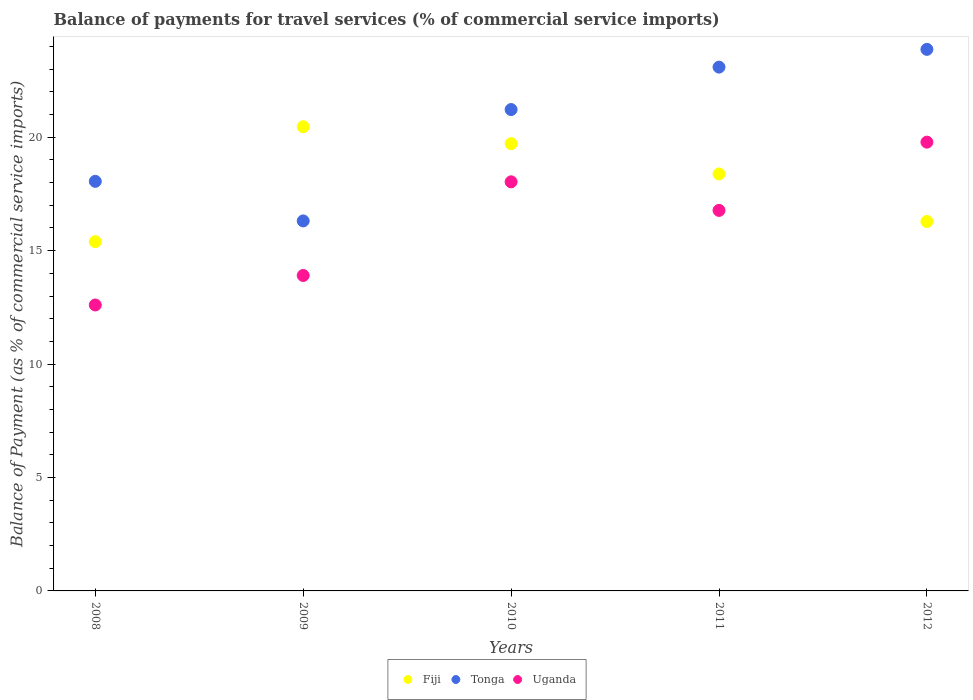What is the balance of payments for travel services in Uganda in 2010?
Your answer should be very brief. 18.03. Across all years, what is the maximum balance of payments for travel services in Fiji?
Give a very brief answer. 20.46. Across all years, what is the minimum balance of payments for travel services in Fiji?
Ensure brevity in your answer.  15.4. What is the total balance of payments for travel services in Tonga in the graph?
Your answer should be compact. 102.55. What is the difference between the balance of payments for travel services in Fiji in 2010 and that in 2011?
Ensure brevity in your answer.  1.34. What is the difference between the balance of payments for travel services in Tonga in 2009 and the balance of payments for travel services in Uganda in 2008?
Make the answer very short. 3.71. What is the average balance of payments for travel services in Fiji per year?
Your answer should be compact. 18.05. In the year 2008, what is the difference between the balance of payments for travel services in Tonga and balance of payments for travel services in Uganda?
Offer a terse response. 5.45. What is the ratio of the balance of payments for travel services in Uganda in 2008 to that in 2010?
Your response must be concise. 0.7. Is the difference between the balance of payments for travel services in Tonga in 2009 and 2010 greater than the difference between the balance of payments for travel services in Uganda in 2009 and 2010?
Your answer should be very brief. No. What is the difference between the highest and the second highest balance of payments for travel services in Tonga?
Keep it short and to the point. 0.78. What is the difference between the highest and the lowest balance of payments for travel services in Uganda?
Give a very brief answer. 7.18. Is the balance of payments for travel services in Uganda strictly greater than the balance of payments for travel services in Fiji over the years?
Offer a terse response. No. Does the graph contain any zero values?
Provide a short and direct response. No. Where does the legend appear in the graph?
Provide a succinct answer. Bottom center. What is the title of the graph?
Your answer should be very brief. Balance of payments for travel services (% of commercial service imports). What is the label or title of the Y-axis?
Your answer should be very brief. Balance of Payment (as % of commercial service imports). What is the Balance of Payment (as % of commercial service imports) in Fiji in 2008?
Ensure brevity in your answer.  15.4. What is the Balance of Payment (as % of commercial service imports) of Tonga in 2008?
Offer a terse response. 18.06. What is the Balance of Payment (as % of commercial service imports) in Uganda in 2008?
Provide a succinct answer. 12.61. What is the Balance of Payment (as % of commercial service imports) in Fiji in 2009?
Keep it short and to the point. 20.46. What is the Balance of Payment (as % of commercial service imports) in Tonga in 2009?
Give a very brief answer. 16.31. What is the Balance of Payment (as % of commercial service imports) of Uganda in 2009?
Provide a succinct answer. 13.91. What is the Balance of Payment (as % of commercial service imports) of Fiji in 2010?
Provide a short and direct response. 19.72. What is the Balance of Payment (as % of commercial service imports) in Tonga in 2010?
Your response must be concise. 21.22. What is the Balance of Payment (as % of commercial service imports) in Uganda in 2010?
Your answer should be compact. 18.03. What is the Balance of Payment (as % of commercial service imports) in Fiji in 2011?
Your answer should be very brief. 18.38. What is the Balance of Payment (as % of commercial service imports) of Tonga in 2011?
Give a very brief answer. 23.09. What is the Balance of Payment (as % of commercial service imports) in Uganda in 2011?
Give a very brief answer. 16.77. What is the Balance of Payment (as % of commercial service imports) of Fiji in 2012?
Provide a short and direct response. 16.28. What is the Balance of Payment (as % of commercial service imports) of Tonga in 2012?
Keep it short and to the point. 23.87. What is the Balance of Payment (as % of commercial service imports) of Uganda in 2012?
Provide a short and direct response. 19.78. Across all years, what is the maximum Balance of Payment (as % of commercial service imports) of Fiji?
Provide a short and direct response. 20.46. Across all years, what is the maximum Balance of Payment (as % of commercial service imports) of Tonga?
Ensure brevity in your answer.  23.87. Across all years, what is the maximum Balance of Payment (as % of commercial service imports) of Uganda?
Provide a succinct answer. 19.78. Across all years, what is the minimum Balance of Payment (as % of commercial service imports) in Fiji?
Keep it short and to the point. 15.4. Across all years, what is the minimum Balance of Payment (as % of commercial service imports) in Tonga?
Make the answer very short. 16.31. Across all years, what is the minimum Balance of Payment (as % of commercial service imports) in Uganda?
Your response must be concise. 12.61. What is the total Balance of Payment (as % of commercial service imports) in Fiji in the graph?
Offer a very short reply. 90.24. What is the total Balance of Payment (as % of commercial service imports) in Tonga in the graph?
Your answer should be compact. 102.55. What is the total Balance of Payment (as % of commercial service imports) in Uganda in the graph?
Offer a very short reply. 81.1. What is the difference between the Balance of Payment (as % of commercial service imports) of Fiji in 2008 and that in 2009?
Keep it short and to the point. -5.07. What is the difference between the Balance of Payment (as % of commercial service imports) of Tonga in 2008 and that in 2009?
Offer a very short reply. 1.74. What is the difference between the Balance of Payment (as % of commercial service imports) in Uganda in 2008 and that in 2009?
Your answer should be very brief. -1.3. What is the difference between the Balance of Payment (as % of commercial service imports) in Fiji in 2008 and that in 2010?
Provide a short and direct response. -4.32. What is the difference between the Balance of Payment (as % of commercial service imports) of Tonga in 2008 and that in 2010?
Make the answer very short. -3.16. What is the difference between the Balance of Payment (as % of commercial service imports) in Uganda in 2008 and that in 2010?
Give a very brief answer. -5.43. What is the difference between the Balance of Payment (as % of commercial service imports) in Fiji in 2008 and that in 2011?
Keep it short and to the point. -2.98. What is the difference between the Balance of Payment (as % of commercial service imports) of Tonga in 2008 and that in 2011?
Ensure brevity in your answer.  -5.03. What is the difference between the Balance of Payment (as % of commercial service imports) of Uganda in 2008 and that in 2011?
Ensure brevity in your answer.  -4.17. What is the difference between the Balance of Payment (as % of commercial service imports) in Fiji in 2008 and that in 2012?
Give a very brief answer. -0.89. What is the difference between the Balance of Payment (as % of commercial service imports) in Tonga in 2008 and that in 2012?
Your response must be concise. -5.82. What is the difference between the Balance of Payment (as % of commercial service imports) of Uganda in 2008 and that in 2012?
Offer a terse response. -7.18. What is the difference between the Balance of Payment (as % of commercial service imports) of Fiji in 2009 and that in 2010?
Provide a succinct answer. 0.75. What is the difference between the Balance of Payment (as % of commercial service imports) of Tonga in 2009 and that in 2010?
Provide a succinct answer. -4.91. What is the difference between the Balance of Payment (as % of commercial service imports) in Uganda in 2009 and that in 2010?
Provide a short and direct response. -4.13. What is the difference between the Balance of Payment (as % of commercial service imports) in Fiji in 2009 and that in 2011?
Your response must be concise. 2.08. What is the difference between the Balance of Payment (as % of commercial service imports) in Tonga in 2009 and that in 2011?
Give a very brief answer. -6.78. What is the difference between the Balance of Payment (as % of commercial service imports) in Uganda in 2009 and that in 2011?
Ensure brevity in your answer.  -2.87. What is the difference between the Balance of Payment (as % of commercial service imports) of Fiji in 2009 and that in 2012?
Make the answer very short. 4.18. What is the difference between the Balance of Payment (as % of commercial service imports) of Tonga in 2009 and that in 2012?
Your response must be concise. -7.56. What is the difference between the Balance of Payment (as % of commercial service imports) in Uganda in 2009 and that in 2012?
Keep it short and to the point. -5.88. What is the difference between the Balance of Payment (as % of commercial service imports) of Fiji in 2010 and that in 2011?
Keep it short and to the point. 1.34. What is the difference between the Balance of Payment (as % of commercial service imports) in Tonga in 2010 and that in 2011?
Your answer should be very brief. -1.87. What is the difference between the Balance of Payment (as % of commercial service imports) in Uganda in 2010 and that in 2011?
Give a very brief answer. 1.26. What is the difference between the Balance of Payment (as % of commercial service imports) of Fiji in 2010 and that in 2012?
Your answer should be compact. 3.43. What is the difference between the Balance of Payment (as % of commercial service imports) of Tonga in 2010 and that in 2012?
Offer a terse response. -2.65. What is the difference between the Balance of Payment (as % of commercial service imports) of Uganda in 2010 and that in 2012?
Ensure brevity in your answer.  -1.75. What is the difference between the Balance of Payment (as % of commercial service imports) of Fiji in 2011 and that in 2012?
Provide a succinct answer. 2.1. What is the difference between the Balance of Payment (as % of commercial service imports) of Tonga in 2011 and that in 2012?
Your response must be concise. -0.78. What is the difference between the Balance of Payment (as % of commercial service imports) in Uganda in 2011 and that in 2012?
Provide a succinct answer. -3.01. What is the difference between the Balance of Payment (as % of commercial service imports) in Fiji in 2008 and the Balance of Payment (as % of commercial service imports) in Tonga in 2009?
Ensure brevity in your answer.  -0.91. What is the difference between the Balance of Payment (as % of commercial service imports) in Fiji in 2008 and the Balance of Payment (as % of commercial service imports) in Uganda in 2009?
Ensure brevity in your answer.  1.49. What is the difference between the Balance of Payment (as % of commercial service imports) of Tonga in 2008 and the Balance of Payment (as % of commercial service imports) of Uganda in 2009?
Offer a terse response. 4.15. What is the difference between the Balance of Payment (as % of commercial service imports) in Fiji in 2008 and the Balance of Payment (as % of commercial service imports) in Tonga in 2010?
Provide a short and direct response. -5.82. What is the difference between the Balance of Payment (as % of commercial service imports) of Fiji in 2008 and the Balance of Payment (as % of commercial service imports) of Uganda in 2010?
Keep it short and to the point. -2.64. What is the difference between the Balance of Payment (as % of commercial service imports) of Tonga in 2008 and the Balance of Payment (as % of commercial service imports) of Uganda in 2010?
Your answer should be compact. 0.02. What is the difference between the Balance of Payment (as % of commercial service imports) of Fiji in 2008 and the Balance of Payment (as % of commercial service imports) of Tonga in 2011?
Offer a terse response. -7.69. What is the difference between the Balance of Payment (as % of commercial service imports) in Fiji in 2008 and the Balance of Payment (as % of commercial service imports) in Uganda in 2011?
Your response must be concise. -1.38. What is the difference between the Balance of Payment (as % of commercial service imports) of Tonga in 2008 and the Balance of Payment (as % of commercial service imports) of Uganda in 2011?
Your answer should be compact. 1.28. What is the difference between the Balance of Payment (as % of commercial service imports) of Fiji in 2008 and the Balance of Payment (as % of commercial service imports) of Tonga in 2012?
Provide a short and direct response. -8.48. What is the difference between the Balance of Payment (as % of commercial service imports) in Fiji in 2008 and the Balance of Payment (as % of commercial service imports) in Uganda in 2012?
Your response must be concise. -4.39. What is the difference between the Balance of Payment (as % of commercial service imports) in Tonga in 2008 and the Balance of Payment (as % of commercial service imports) in Uganda in 2012?
Your answer should be very brief. -1.73. What is the difference between the Balance of Payment (as % of commercial service imports) in Fiji in 2009 and the Balance of Payment (as % of commercial service imports) in Tonga in 2010?
Provide a short and direct response. -0.76. What is the difference between the Balance of Payment (as % of commercial service imports) in Fiji in 2009 and the Balance of Payment (as % of commercial service imports) in Uganda in 2010?
Provide a short and direct response. 2.43. What is the difference between the Balance of Payment (as % of commercial service imports) in Tonga in 2009 and the Balance of Payment (as % of commercial service imports) in Uganda in 2010?
Your response must be concise. -1.72. What is the difference between the Balance of Payment (as % of commercial service imports) in Fiji in 2009 and the Balance of Payment (as % of commercial service imports) in Tonga in 2011?
Offer a terse response. -2.63. What is the difference between the Balance of Payment (as % of commercial service imports) of Fiji in 2009 and the Balance of Payment (as % of commercial service imports) of Uganda in 2011?
Offer a very short reply. 3.69. What is the difference between the Balance of Payment (as % of commercial service imports) of Tonga in 2009 and the Balance of Payment (as % of commercial service imports) of Uganda in 2011?
Provide a succinct answer. -0.46. What is the difference between the Balance of Payment (as % of commercial service imports) of Fiji in 2009 and the Balance of Payment (as % of commercial service imports) of Tonga in 2012?
Your answer should be very brief. -3.41. What is the difference between the Balance of Payment (as % of commercial service imports) of Fiji in 2009 and the Balance of Payment (as % of commercial service imports) of Uganda in 2012?
Keep it short and to the point. 0.68. What is the difference between the Balance of Payment (as % of commercial service imports) of Tonga in 2009 and the Balance of Payment (as % of commercial service imports) of Uganda in 2012?
Provide a short and direct response. -3.47. What is the difference between the Balance of Payment (as % of commercial service imports) of Fiji in 2010 and the Balance of Payment (as % of commercial service imports) of Tonga in 2011?
Keep it short and to the point. -3.37. What is the difference between the Balance of Payment (as % of commercial service imports) of Fiji in 2010 and the Balance of Payment (as % of commercial service imports) of Uganda in 2011?
Your answer should be compact. 2.94. What is the difference between the Balance of Payment (as % of commercial service imports) of Tonga in 2010 and the Balance of Payment (as % of commercial service imports) of Uganda in 2011?
Your answer should be very brief. 4.45. What is the difference between the Balance of Payment (as % of commercial service imports) of Fiji in 2010 and the Balance of Payment (as % of commercial service imports) of Tonga in 2012?
Your answer should be very brief. -4.16. What is the difference between the Balance of Payment (as % of commercial service imports) of Fiji in 2010 and the Balance of Payment (as % of commercial service imports) of Uganda in 2012?
Provide a succinct answer. -0.07. What is the difference between the Balance of Payment (as % of commercial service imports) in Tonga in 2010 and the Balance of Payment (as % of commercial service imports) in Uganda in 2012?
Your response must be concise. 1.44. What is the difference between the Balance of Payment (as % of commercial service imports) in Fiji in 2011 and the Balance of Payment (as % of commercial service imports) in Tonga in 2012?
Provide a short and direct response. -5.49. What is the difference between the Balance of Payment (as % of commercial service imports) of Fiji in 2011 and the Balance of Payment (as % of commercial service imports) of Uganda in 2012?
Your answer should be very brief. -1.4. What is the difference between the Balance of Payment (as % of commercial service imports) in Tonga in 2011 and the Balance of Payment (as % of commercial service imports) in Uganda in 2012?
Offer a very short reply. 3.31. What is the average Balance of Payment (as % of commercial service imports) in Fiji per year?
Make the answer very short. 18.05. What is the average Balance of Payment (as % of commercial service imports) of Tonga per year?
Offer a terse response. 20.51. What is the average Balance of Payment (as % of commercial service imports) of Uganda per year?
Offer a terse response. 16.22. In the year 2008, what is the difference between the Balance of Payment (as % of commercial service imports) of Fiji and Balance of Payment (as % of commercial service imports) of Tonga?
Your response must be concise. -2.66. In the year 2008, what is the difference between the Balance of Payment (as % of commercial service imports) in Fiji and Balance of Payment (as % of commercial service imports) in Uganda?
Your answer should be compact. 2.79. In the year 2008, what is the difference between the Balance of Payment (as % of commercial service imports) in Tonga and Balance of Payment (as % of commercial service imports) in Uganda?
Your answer should be very brief. 5.45. In the year 2009, what is the difference between the Balance of Payment (as % of commercial service imports) in Fiji and Balance of Payment (as % of commercial service imports) in Tonga?
Your answer should be compact. 4.15. In the year 2009, what is the difference between the Balance of Payment (as % of commercial service imports) of Fiji and Balance of Payment (as % of commercial service imports) of Uganda?
Provide a short and direct response. 6.56. In the year 2009, what is the difference between the Balance of Payment (as % of commercial service imports) of Tonga and Balance of Payment (as % of commercial service imports) of Uganda?
Offer a terse response. 2.41. In the year 2010, what is the difference between the Balance of Payment (as % of commercial service imports) of Fiji and Balance of Payment (as % of commercial service imports) of Tonga?
Provide a short and direct response. -1.5. In the year 2010, what is the difference between the Balance of Payment (as % of commercial service imports) of Fiji and Balance of Payment (as % of commercial service imports) of Uganda?
Offer a terse response. 1.68. In the year 2010, what is the difference between the Balance of Payment (as % of commercial service imports) of Tonga and Balance of Payment (as % of commercial service imports) of Uganda?
Offer a terse response. 3.19. In the year 2011, what is the difference between the Balance of Payment (as % of commercial service imports) of Fiji and Balance of Payment (as % of commercial service imports) of Tonga?
Provide a succinct answer. -4.71. In the year 2011, what is the difference between the Balance of Payment (as % of commercial service imports) of Fiji and Balance of Payment (as % of commercial service imports) of Uganda?
Offer a very short reply. 1.61. In the year 2011, what is the difference between the Balance of Payment (as % of commercial service imports) of Tonga and Balance of Payment (as % of commercial service imports) of Uganda?
Keep it short and to the point. 6.32. In the year 2012, what is the difference between the Balance of Payment (as % of commercial service imports) in Fiji and Balance of Payment (as % of commercial service imports) in Tonga?
Your response must be concise. -7.59. In the year 2012, what is the difference between the Balance of Payment (as % of commercial service imports) in Fiji and Balance of Payment (as % of commercial service imports) in Uganda?
Provide a short and direct response. -3.5. In the year 2012, what is the difference between the Balance of Payment (as % of commercial service imports) in Tonga and Balance of Payment (as % of commercial service imports) in Uganda?
Your response must be concise. 4.09. What is the ratio of the Balance of Payment (as % of commercial service imports) in Fiji in 2008 to that in 2009?
Keep it short and to the point. 0.75. What is the ratio of the Balance of Payment (as % of commercial service imports) in Tonga in 2008 to that in 2009?
Make the answer very short. 1.11. What is the ratio of the Balance of Payment (as % of commercial service imports) in Uganda in 2008 to that in 2009?
Make the answer very short. 0.91. What is the ratio of the Balance of Payment (as % of commercial service imports) of Fiji in 2008 to that in 2010?
Keep it short and to the point. 0.78. What is the ratio of the Balance of Payment (as % of commercial service imports) of Tonga in 2008 to that in 2010?
Give a very brief answer. 0.85. What is the ratio of the Balance of Payment (as % of commercial service imports) in Uganda in 2008 to that in 2010?
Provide a short and direct response. 0.7. What is the ratio of the Balance of Payment (as % of commercial service imports) in Fiji in 2008 to that in 2011?
Your answer should be very brief. 0.84. What is the ratio of the Balance of Payment (as % of commercial service imports) in Tonga in 2008 to that in 2011?
Ensure brevity in your answer.  0.78. What is the ratio of the Balance of Payment (as % of commercial service imports) of Uganda in 2008 to that in 2011?
Offer a terse response. 0.75. What is the ratio of the Balance of Payment (as % of commercial service imports) of Fiji in 2008 to that in 2012?
Provide a succinct answer. 0.95. What is the ratio of the Balance of Payment (as % of commercial service imports) in Tonga in 2008 to that in 2012?
Make the answer very short. 0.76. What is the ratio of the Balance of Payment (as % of commercial service imports) of Uganda in 2008 to that in 2012?
Offer a very short reply. 0.64. What is the ratio of the Balance of Payment (as % of commercial service imports) in Fiji in 2009 to that in 2010?
Give a very brief answer. 1.04. What is the ratio of the Balance of Payment (as % of commercial service imports) of Tonga in 2009 to that in 2010?
Offer a very short reply. 0.77. What is the ratio of the Balance of Payment (as % of commercial service imports) of Uganda in 2009 to that in 2010?
Offer a very short reply. 0.77. What is the ratio of the Balance of Payment (as % of commercial service imports) in Fiji in 2009 to that in 2011?
Your answer should be compact. 1.11. What is the ratio of the Balance of Payment (as % of commercial service imports) of Tonga in 2009 to that in 2011?
Make the answer very short. 0.71. What is the ratio of the Balance of Payment (as % of commercial service imports) in Uganda in 2009 to that in 2011?
Ensure brevity in your answer.  0.83. What is the ratio of the Balance of Payment (as % of commercial service imports) of Fiji in 2009 to that in 2012?
Your response must be concise. 1.26. What is the ratio of the Balance of Payment (as % of commercial service imports) of Tonga in 2009 to that in 2012?
Offer a terse response. 0.68. What is the ratio of the Balance of Payment (as % of commercial service imports) in Uganda in 2009 to that in 2012?
Your answer should be compact. 0.7. What is the ratio of the Balance of Payment (as % of commercial service imports) in Fiji in 2010 to that in 2011?
Provide a succinct answer. 1.07. What is the ratio of the Balance of Payment (as % of commercial service imports) in Tonga in 2010 to that in 2011?
Ensure brevity in your answer.  0.92. What is the ratio of the Balance of Payment (as % of commercial service imports) of Uganda in 2010 to that in 2011?
Give a very brief answer. 1.08. What is the ratio of the Balance of Payment (as % of commercial service imports) of Fiji in 2010 to that in 2012?
Your answer should be compact. 1.21. What is the ratio of the Balance of Payment (as % of commercial service imports) in Tonga in 2010 to that in 2012?
Your response must be concise. 0.89. What is the ratio of the Balance of Payment (as % of commercial service imports) of Uganda in 2010 to that in 2012?
Your answer should be compact. 0.91. What is the ratio of the Balance of Payment (as % of commercial service imports) of Fiji in 2011 to that in 2012?
Your answer should be very brief. 1.13. What is the ratio of the Balance of Payment (as % of commercial service imports) of Tonga in 2011 to that in 2012?
Offer a very short reply. 0.97. What is the ratio of the Balance of Payment (as % of commercial service imports) of Uganda in 2011 to that in 2012?
Offer a very short reply. 0.85. What is the difference between the highest and the second highest Balance of Payment (as % of commercial service imports) in Fiji?
Provide a short and direct response. 0.75. What is the difference between the highest and the second highest Balance of Payment (as % of commercial service imports) of Tonga?
Provide a short and direct response. 0.78. What is the difference between the highest and the second highest Balance of Payment (as % of commercial service imports) in Uganda?
Make the answer very short. 1.75. What is the difference between the highest and the lowest Balance of Payment (as % of commercial service imports) in Fiji?
Keep it short and to the point. 5.07. What is the difference between the highest and the lowest Balance of Payment (as % of commercial service imports) in Tonga?
Your answer should be compact. 7.56. What is the difference between the highest and the lowest Balance of Payment (as % of commercial service imports) of Uganda?
Your response must be concise. 7.18. 